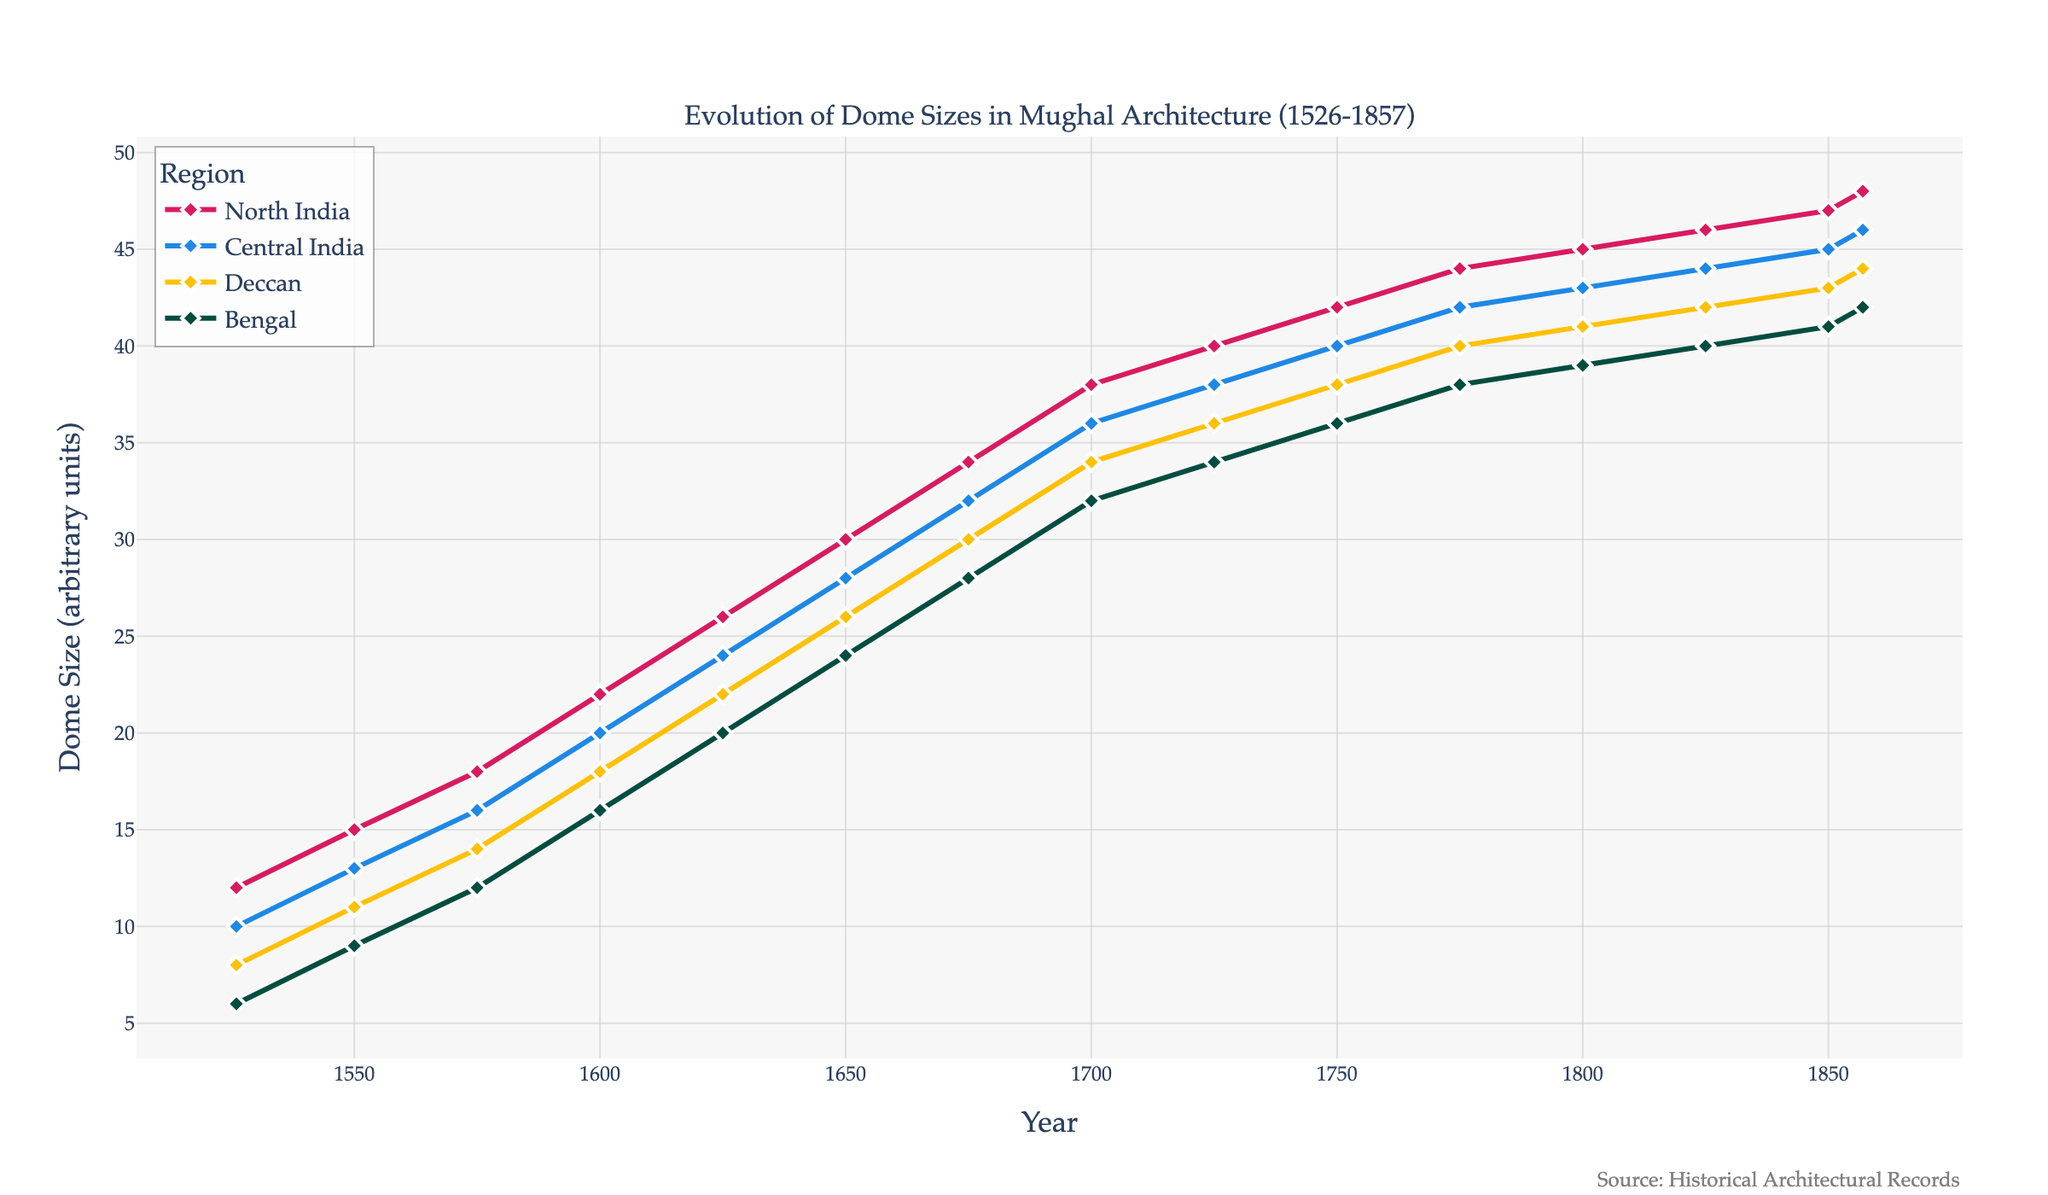What's the average dome size in North India from 1526 to 1857? To find the average dome size in North India, sum up all the values and divide by the number of entries. (12 + 15 + 18 + 22 + 26 + 30 + 34 + 38 + 40 + 42 + 44 + 45 + 46 + 47 + 48) = 516. There are 15 data points, so the average is 516/15 = 34.4
Answer: 34.4 Which region showed the largest increase in dome size from 1526 to 1857? To determine the largest increase, subtract the 1526 dome size from the 1857 dome size for each region. North India: 48 - 12 = 36, Central India: 46 - 10 = 36, Deccan: 44 - 8 = 36, Bengal: 42 - 6 = 36. All regions showed the same increase of 36 units.
Answer: All regions What is the difference in dome size between North India and Bengal in 1750? Refer to the figure to get the dome sizes in 1750: North India = 42, Bengal = 36. The difference is 42 - 36 = 6.
Answer: 6 During which period did Central India's dome size surpass 20 units? Find when the dome size of Central India first exceeds 20 from the plot: It happens between 1600 and 1625 as in 1600 it is 20 and in 1625 it is 24.
Answer: Between 1600 and 1625 Which region had the smallest dome size in 1600? By checking the 1600 values in the figure, North India = 22, Central India = 20, Deccan = 18, Bengal = 16. The smallest size is Bengal with 16 units.
Answer: Bengal By how much did the dome size in the Deccan region increase between 1550 and 1700? From the data: Deccan's dome size in 1550 = 11, in 1700 = 34. The increase is 34 - 11 = 23.
Answer: 23 Compare the dome sizes of all regions in 1850. Which region had the second smallest dome size? From the figure: North India = 47, Central India = 45, Deccan = 43, Bengal = 41. The second smallest is Deccan with 43 units.
Answer: Deccan Describe the overall trend in dome sizes in all the regions from 1526 to 1857. The overall trend in all regions shows a steady increase in dome sizes from 1526 to 1857.
Answer: Steady increase In which year did Bengal's dome size reach 40 units? By looking at the values, Bengal's dome size reaches 40 units in 1825.
Answer: 1825 